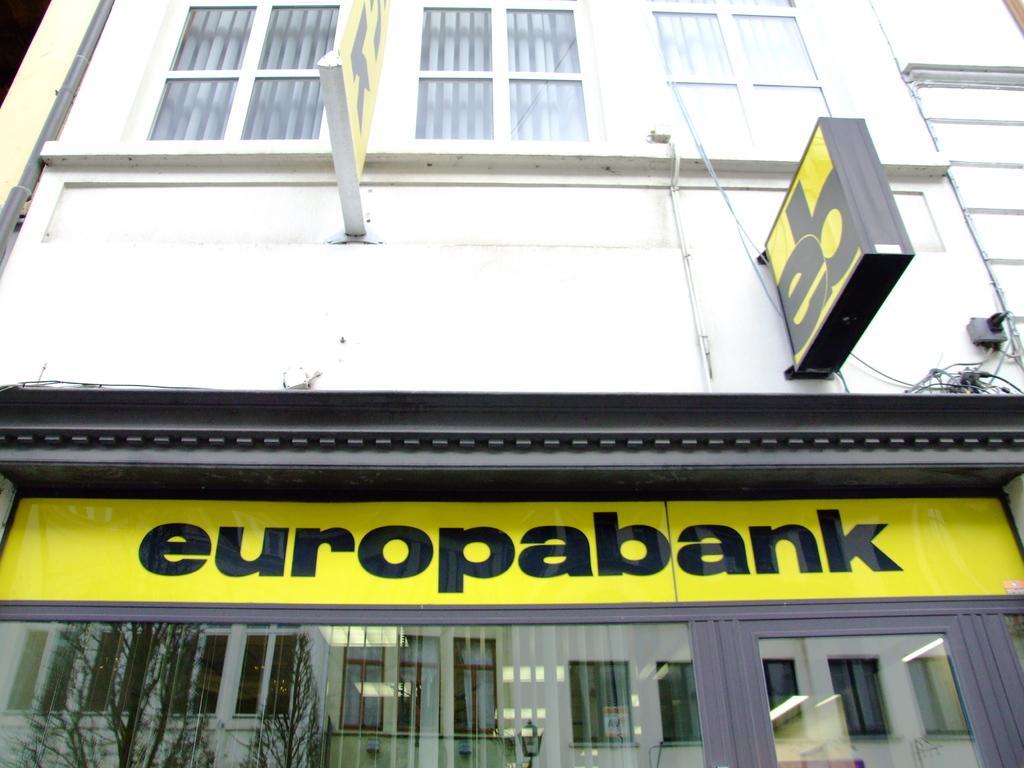Please provide a concise description of this image. In this image, we can see a building, wall, glass windows, board, banner, pipe and wires. At the bottom, we can see glass objects and hoarding. On the glass objects, we can see buildings, walls, windows, trees and light. 